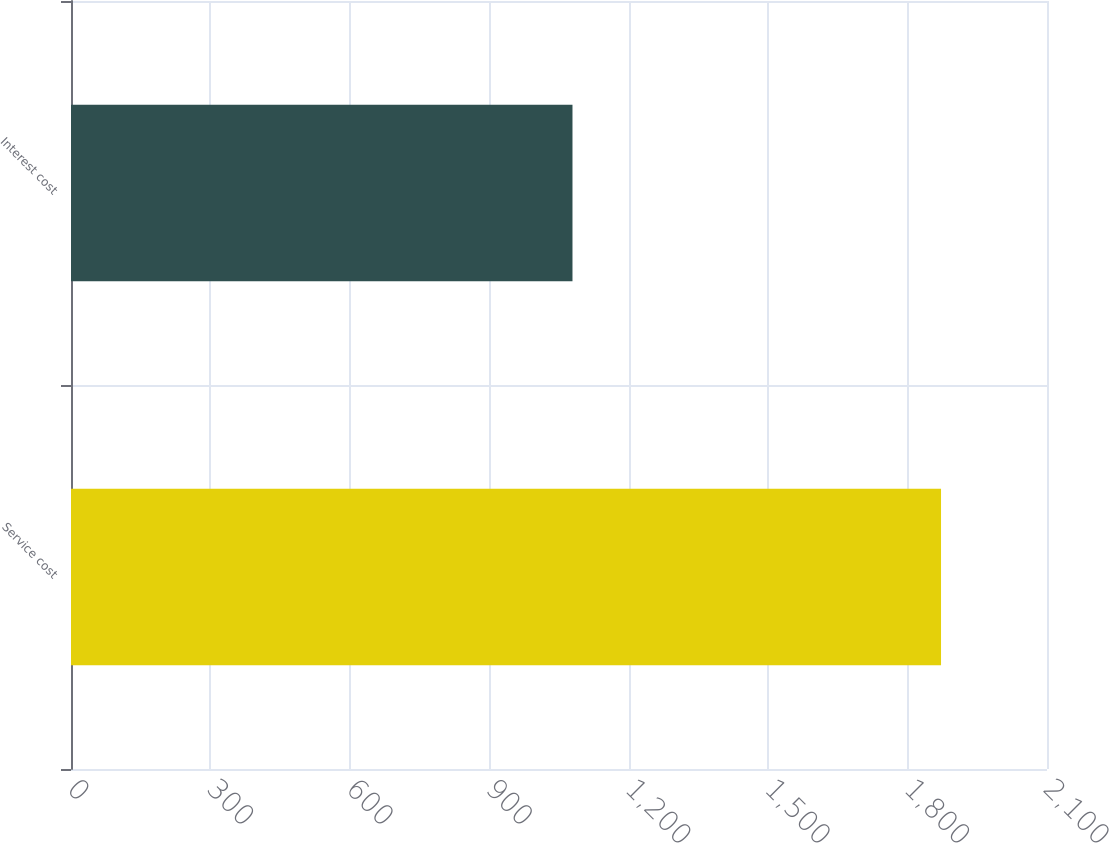Convert chart. <chart><loc_0><loc_0><loc_500><loc_500><bar_chart><fcel>Service cost<fcel>Interest cost<nl><fcel>1872<fcel>1079<nl></chart> 